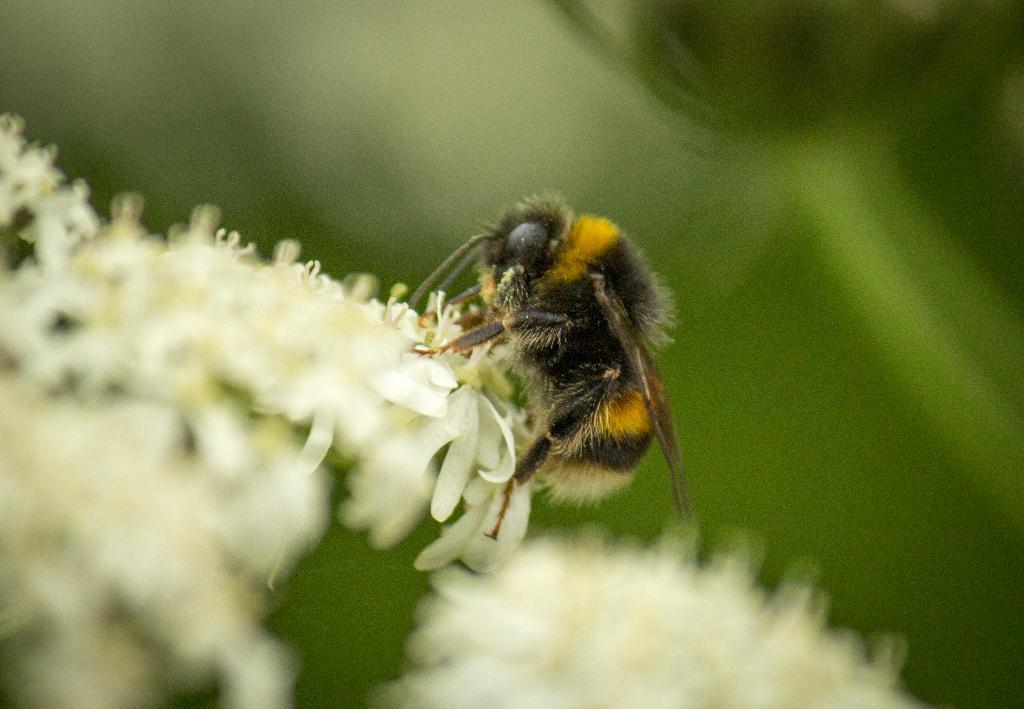What type of living organisms can be seen in the image? The image contains flowers. Are there any other creatures present in the image? Yes, there is an insect on the flowers. What type of reward is the insect receiving for sitting on the flowers in the image? There is no indication in the image that the insect is receiving any reward for sitting on the flowers. 